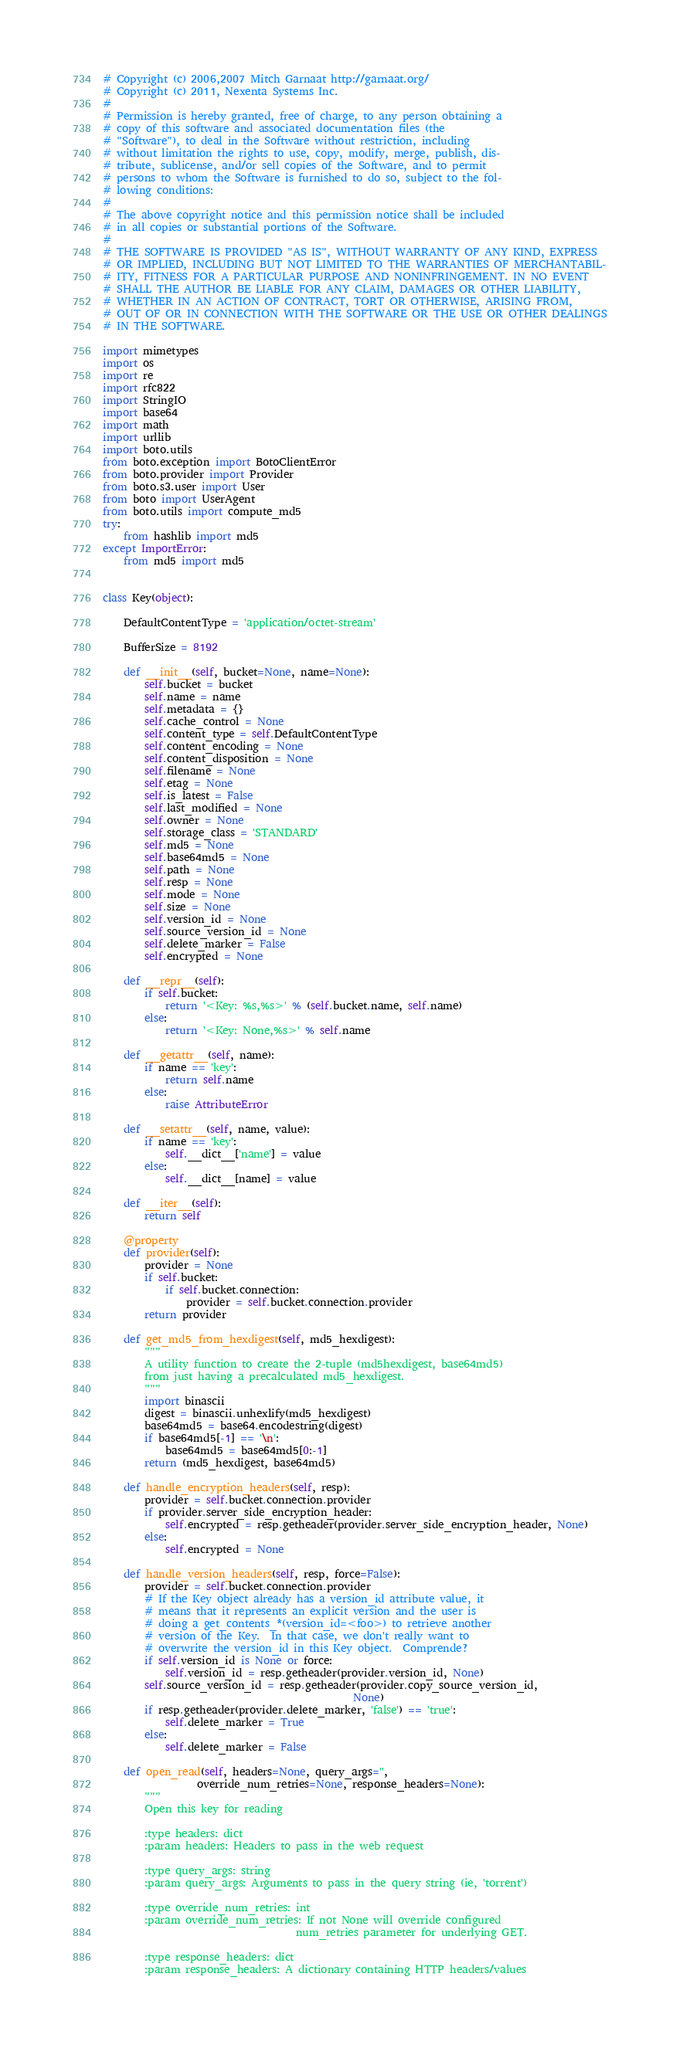Convert code to text. <code><loc_0><loc_0><loc_500><loc_500><_Python_># Copyright (c) 2006,2007 Mitch Garnaat http://garnaat.org/
# Copyright (c) 2011, Nexenta Systems Inc.
#
# Permission is hereby granted, free of charge, to any person obtaining a
# copy of this software and associated documentation files (the
# "Software"), to deal in the Software without restriction, including
# without limitation the rights to use, copy, modify, merge, publish, dis-
# tribute, sublicense, and/or sell copies of the Software, and to permit
# persons to whom the Software is furnished to do so, subject to the fol-
# lowing conditions:
#
# The above copyright notice and this permission notice shall be included
# in all copies or substantial portions of the Software.
#
# THE SOFTWARE IS PROVIDED "AS IS", WITHOUT WARRANTY OF ANY KIND, EXPRESS
# OR IMPLIED, INCLUDING BUT NOT LIMITED TO THE WARRANTIES OF MERCHANTABIL-
# ITY, FITNESS FOR A PARTICULAR PURPOSE AND NONINFRINGEMENT. IN NO EVENT
# SHALL THE AUTHOR BE LIABLE FOR ANY CLAIM, DAMAGES OR OTHER LIABILITY,
# WHETHER IN AN ACTION OF CONTRACT, TORT OR OTHERWISE, ARISING FROM,
# OUT OF OR IN CONNECTION WITH THE SOFTWARE OR THE USE OR OTHER DEALINGS
# IN THE SOFTWARE.

import mimetypes
import os
import re
import rfc822
import StringIO
import base64
import math
import urllib
import boto.utils
from boto.exception import BotoClientError
from boto.provider import Provider
from boto.s3.user import User
from boto import UserAgent
from boto.utils import compute_md5
try:
    from hashlib import md5
except ImportError:
    from md5 import md5


class Key(object):

    DefaultContentType = 'application/octet-stream'

    BufferSize = 8192

    def __init__(self, bucket=None, name=None):
        self.bucket = bucket
        self.name = name
        self.metadata = {}
        self.cache_control = None
        self.content_type = self.DefaultContentType
        self.content_encoding = None
        self.content_disposition = None
        self.filename = None
        self.etag = None
        self.is_latest = False
        self.last_modified = None
        self.owner = None
        self.storage_class = 'STANDARD'
        self.md5 = None
        self.base64md5 = None
        self.path = None
        self.resp = None
        self.mode = None
        self.size = None
        self.version_id = None
        self.source_version_id = None
        self.delete_marker = False
        self.encrypted = None

    def __repr__(self):
        if self.bucket:
            return '<Key: %s,%s>' % (self.bucket.name, self.name)
        else:
            return '<Key: None,%s>' % self.name

    def __getattr__(self, name):
        if name == 'key':
            return self.name
        else:
            raise AttributeError

    def __setattr__(self, name, value):
        if name == 'key':
            self.__dict__['name'] = value
        else:
            self.__dict__[name] = value

    def __iter__(self):
        return self

    @property
    def provider(self):
        provider = None
        if self.bucket:
            if self.bucket.connection:
                provider = self.bucket.connection.provider
        return provider

    def get_md5_from_hexdigest(self, md5_hexdigest):
        """
        A utility function to create the 2-tuple (md5hexdigest, base64md5)
        from just having a precalculated md5_hexdigest.
        """
        import binascii
        digest = binascii.unhexlify(md5_hexdigest)
        base64md5 = base64.encodestring(digest)
        if base64md5[-1] == '\n':
            base64md5 = base64md5[0:-1]
        return (md5_hexdigest, base64md5)

    def handle_encryption_headers(self, resp):
        provider = self.bucket.connection.provider
        if provider.server_side_encryption_header:
            self.encrypted = resp.getheader(provider.server_side_encryption_header, None)
        else:
            self.encrypted = None

    def handle_version_headers(self, resp, force=False):
        provider = self.bucket.connection.provider
        # If the Key object already has a version_id attribute value, it
        # means that it represents an explicit version and the user is
        # doing a get_contents_*(version_id=<foo>) to retrieve another
        # version of the Key.  In that case, we don't really want to
        # overwrite the version_id in this Key object.  Comprende?
        if self.version_id is None or force:
            self.version_id = resp.getheader(provider.version_id, None)
        self.source_version_id = resp.getheader(provider.copy_source_version_id,
                                                None)
        if resp.getheader(provider.delete_marker, 'false') == 'true':
            self.delete_marker = True
        else:
            self.delete_marker = False

    def open_read(self, headers=None, query_args='',
                  override_num_retries=None, response_headers=None):
        """
        Open this key for reading

        :type headers: dict
        :param headers: Headers to pass in the web request

        :type query_args: string
        :param query_args: Arguments to pass in the query string (ie, 'torrent')

        :type override_num_retries: int
        :param override_num_retries: If not None will override configured
                                     num_retries parameter for underlying GET.

        :type response_headers: dict
        :param response_headers: A dictionary containing HTTP headers/values</code> 